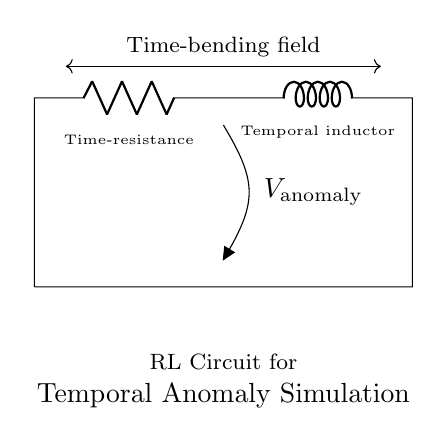What components are present in this circuit? The circuit contains a resistor and an inductor, specifically noted as "R_t" for the resistor and "L_τ" for the inductor.
Answer: resistor, inductor What is the label for the resistor in this diagram? The resistor is labeled as "R_t," which indicates it acts as a time-resistance in the circuit.
Answer: R_t What is the name of the inductor in this circuit? The inductor is represented as "L_τ," which refers to it as a temporal inductor in the context of the circuit's function.
Answer: L_τ What does the open connection at node three represent? The open connection at node three is labeled "V_anomaly," indicating it shows the voltage related to the temporal anomaly simulation in the circuit.
Answer: V_anomaly What is the purpose of the time-bending field indicated in the diagram? The time-bending field represents the interaction between the resistor and inductor that is designed to create a time-altering effect within the anomalies being simulated.
Answer: time-bending field What is the relationship between the resistor and inductor in terms of circuit behavior? The resistor limits current flow while the inductor stores energy in a magnetic field, together creating a time-dependent behavior in the circuit, which is fundamental for simulating temporal anomalies.
Answer: time-dependent behavior What does "V_anomaly" indicate regarding voltage? "V_anomaly" indicates the potential difference associated with the simulation of temporal anomalies, crucial for the circuit's purpose in creating these effects.
Answer: potential difference 